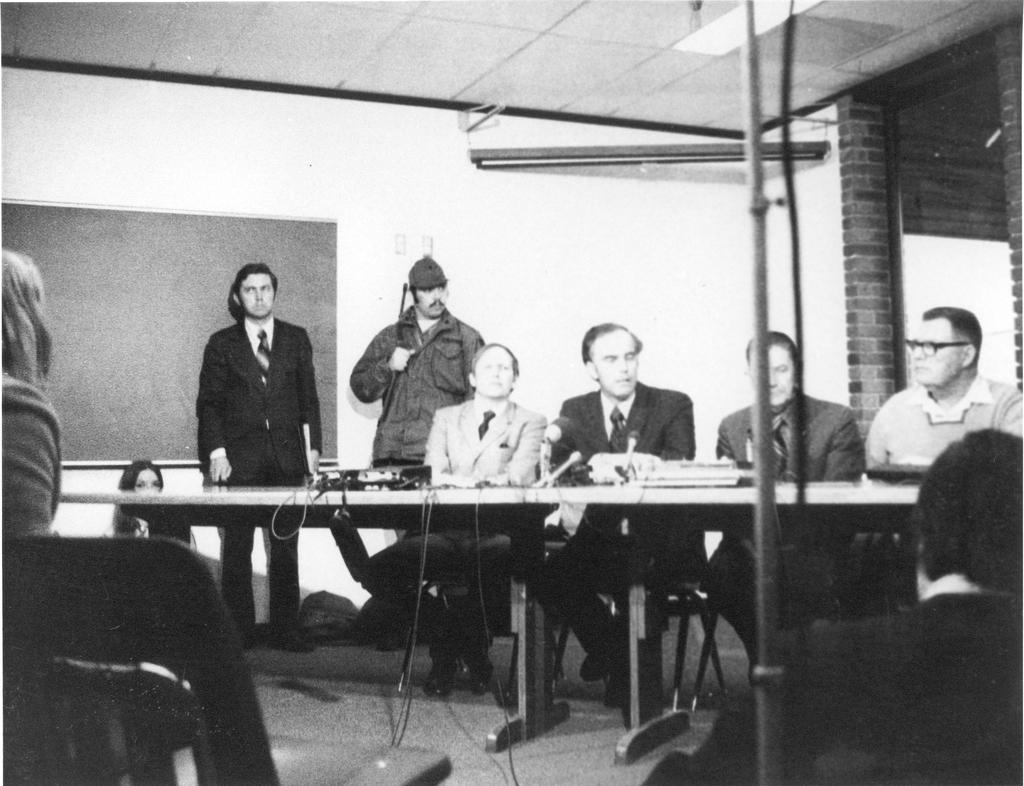What is the main object in the image? There is a black color board in the image. What can be seen behind the color board? There is a wall in the image. What is present in front of the color board? There is a table in the image. Who is present in the image? There are people sitting on chairs in the image. What type of flowers are growing on the color board in the image? There are no flowers present on the color board in the image. 